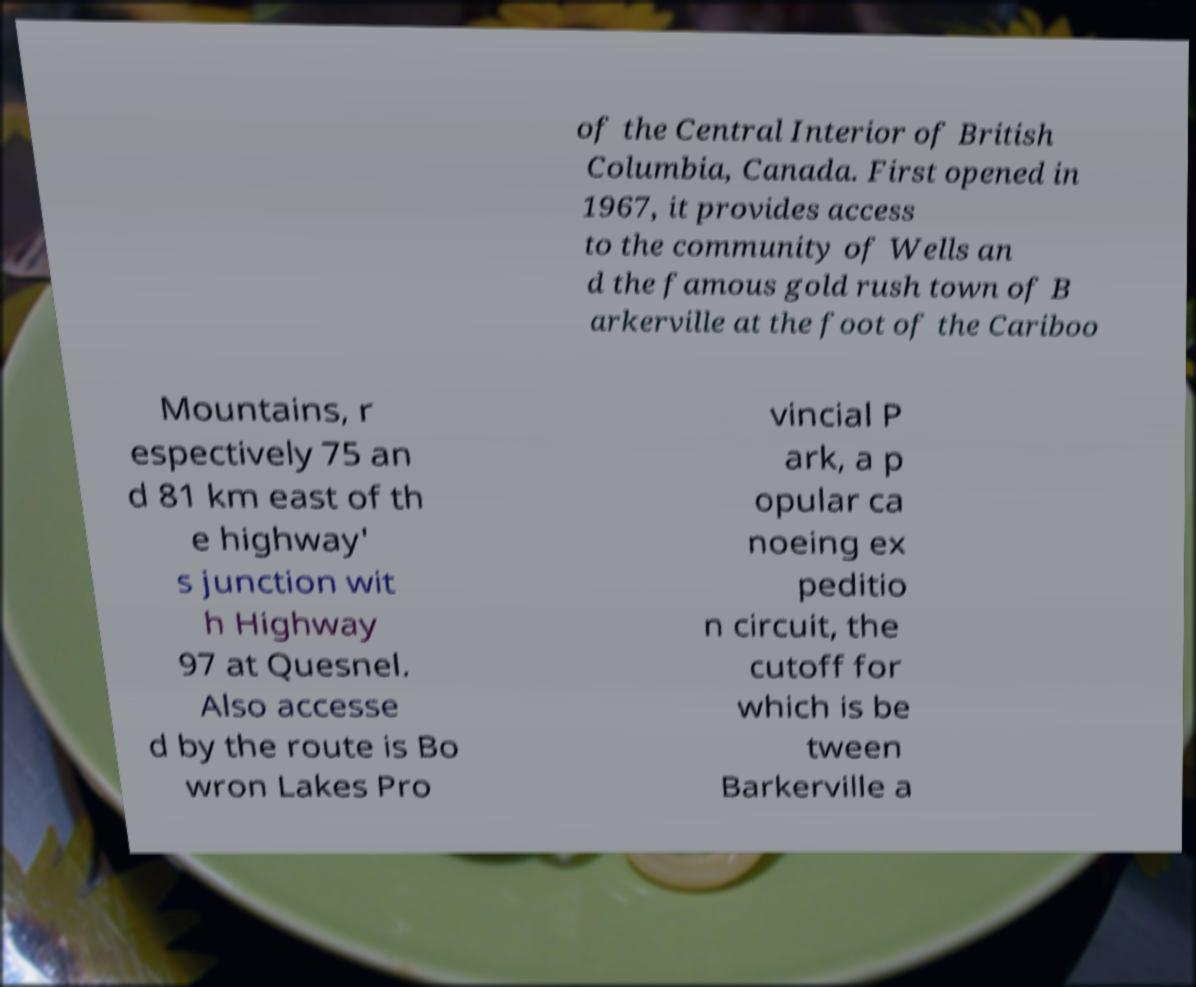I need the written content from this picture converted into text. Can you do that? of the Central Interior of British Columbia, Canada. First opened in 1967, it provides access to the community of Wells an d the famous gold rush town of B arkerville at the foot of the Cariboo Mountains, r espectively 75 an d 81 km east of th e highway' s junction wit h Highway 97 at Quesnel. Also accesse d by the route is Bo wron Lakes Pro vincial P ark, a p opular ca noeing ex peditio n circuit, the cutoff for which is be tween Barkerville a 